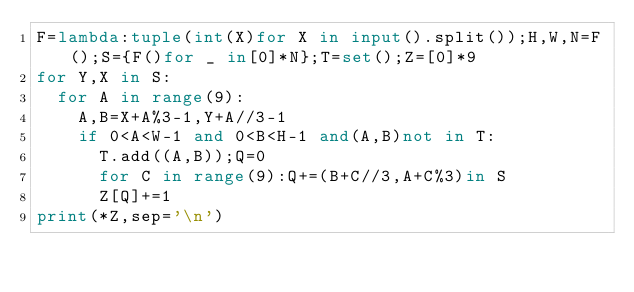Convert code to text. <code><loc_0><loc_0><loc_500><loc_500><_Python_>F=lambda:tuple(int(X)for X in input().split());H,W,N=F();S={F()for _ in[0]*N};T=set();Z=[0]*9
for Y,X in S:
	for A in range(9):
		A,B=X+A%3-1,Y+A//3-1
		if 0<A<W-1 and 0<B<H-1 and(A,B)not in T:
			T.add((A,B));Q=0
			for C in range(9):Q+=(B+C//3,A+C%3)in S
			Z[Q]+=1
print(*Z,sep='\n')</code> 